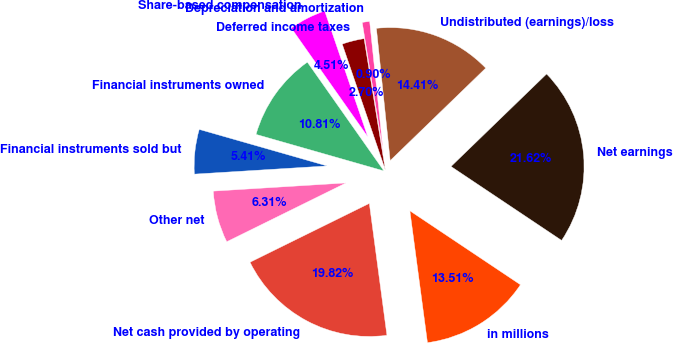<chart> <loc_0><loc_0><loc_500><loc_500><pie_chart><fcel>in millions<fcel>Net earnings<fcel>Undistributed (earnings)/loss<fcel>Depreciation and amortization<fcel>Deferred income taxes<fcel>Share-based compensation<fcel>Financial instruments owned<fcel>Financial instruments sold but<fcel>Other net<fcel>Net cash provided by operating<nl><fcel>13.51%<fcel>21.62%<fcel>14.41%<fcel>0.9%<fcel>2.7%<fcel>4.51%<fcel>10.81%<fcel>5.41%<fcel>6.31%<fcel>19.82%<nl></chart> 